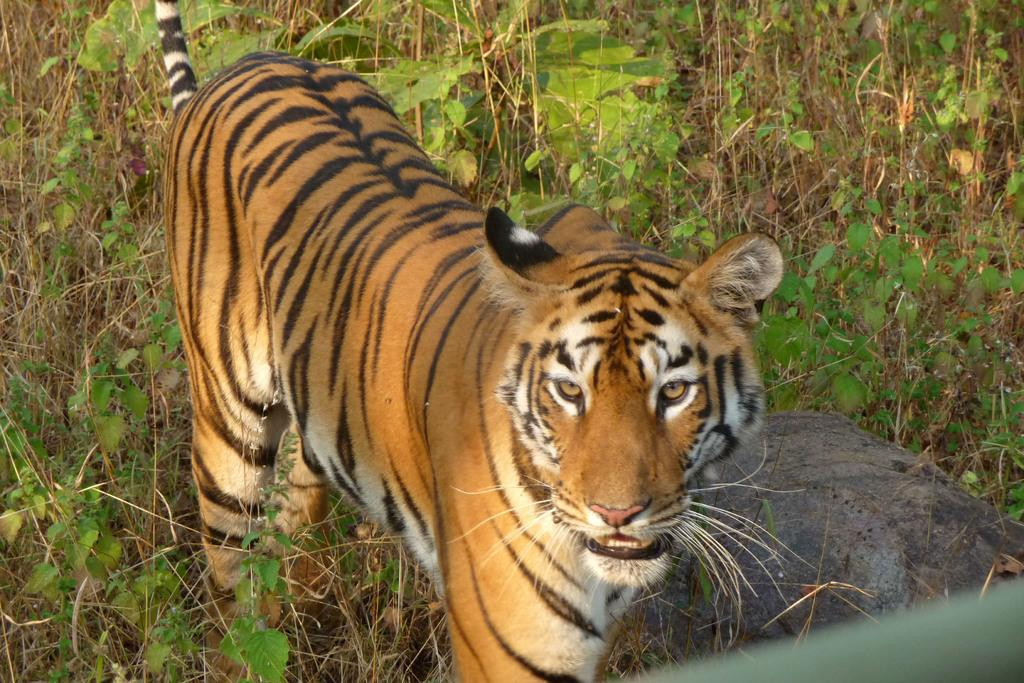What type of animal is in the image? There is a tiger in the image. What other elements can be seen in the image besides the tiger? There are plants and a rock towards the right side of the image. Is there any object located at the bottom of the image? Yes, there is an object towards the bottom of the image. What type of gate can be seen in the image? There is no gate present in the image. 